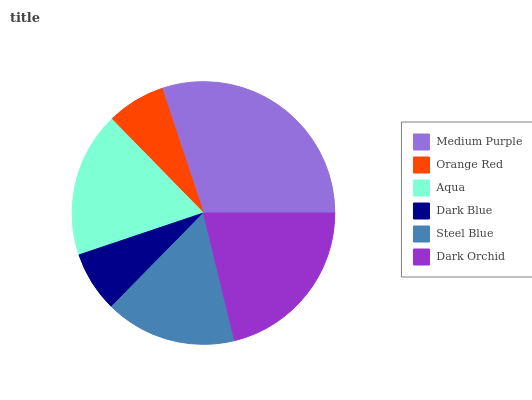Is Orange Red the minimum?
Answer yes or no. Yes. Is Medium Purple the maximum?
Answer yes or no. Yes. Is Aqua the minimum?
Answer yes or no. No. Is Aqua the maximum?
Answer yes or no. No. Is Aqua greater than Orange Red?
Answer yes or no. Yes. Is Orange Red less than Aqua?
Answer yes or no. Yes. Is Orange Red greater than Aqua?
Answer yes or no. No. Is Aqua less than Orange Red?
Answer yes or no. No. Is Aqua the high median?
Answer yes or no. Yes. Is Steel Blue the low median?
Answer yes or no. Yes. Is Medium Purple the high median?
Answer yes or no. No. Is Medium Purple the low median?
Answer yes or no. No. 